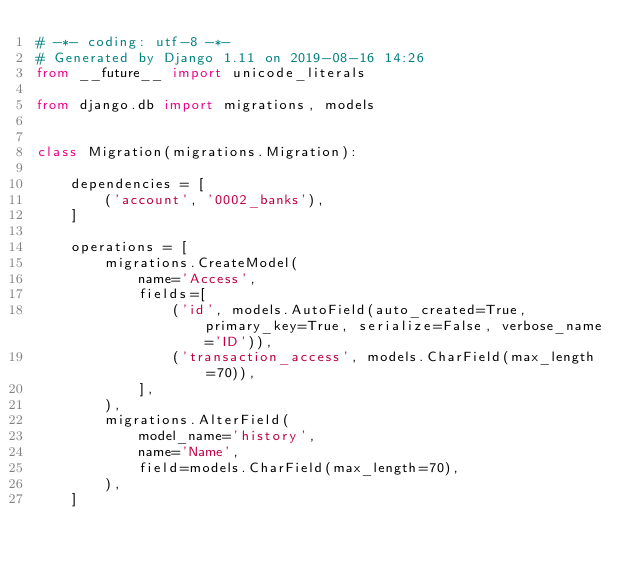<code> <loc_0><loc_0><loc_500><loc_500><_Python_># -*- coding: utf-8 -*-
# Generated by Django 1.11 on 2019-08-16 14:26
from __future__ import unicode_literals

from django.db import migrations, models


class Migration(migrations.Migration):

    dependencies = [
        ('account', '0002_banks'),
    ]

    operations = [
        migrations.CreateModel(
            name='Access',
            fields=[
                ('id', models.AutoField(auto_created=True, primary_key=True, serialize=False, verbose_name='ID')),
                ('transaction_access', models.CharField(max_length=70)),
            ],
        ),
        migrations.AlterField(
            model_name='history',
            name='Name',
            field=models.CharField(max_length=70),
        ),
    ]
</code> 